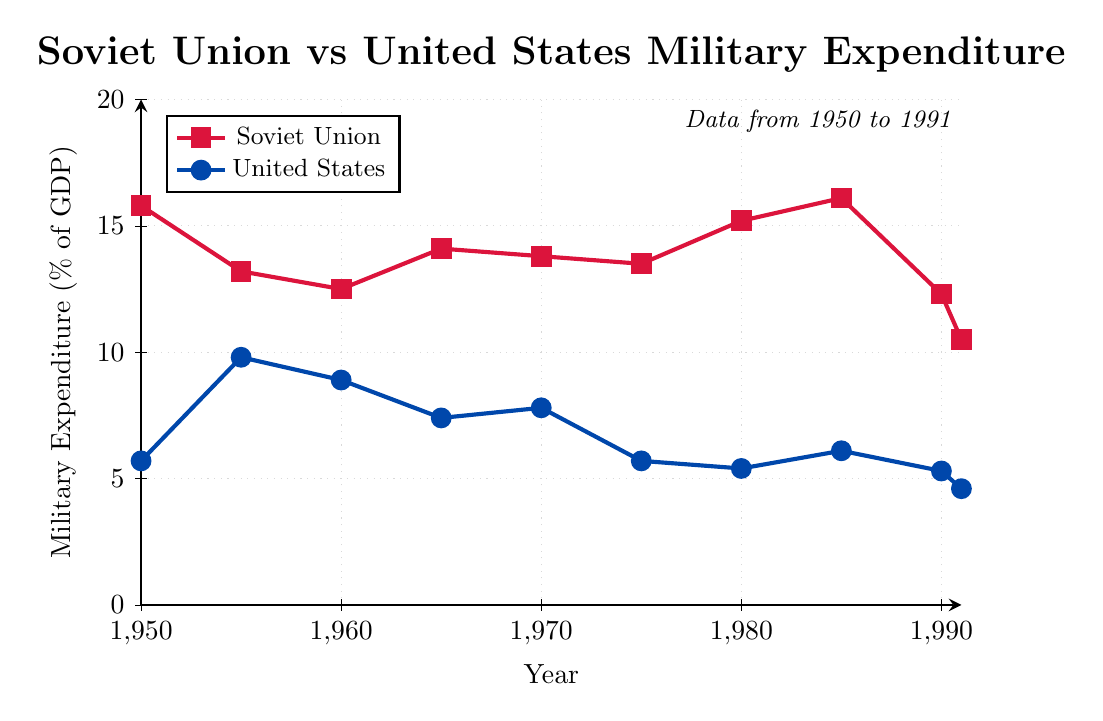What's the lowest military expenditure percentage for the Soviet Union? From the figure, the lowest point in the red line representing the Soviet Union's military expenditure is in 1991, which is 10.5% of GDP.
Answer: 10.5% Which country had a higher military expenditure percentage in 1950? By comparing the y-values at 1950 in the plot, the Soviet Union had a military expenditure of 15.8%, while the United States had 5.7%. Thus, the Soviet Union had a higher percentage.
Answer: Soviet Union During which year was the military expenditure percentage of the United States the highest? The highest point in the blue line representing the United States is in 1955, with a value of 9.8% of GDP.
Answer: 1955 What is the average military expenditure percentage for the Soviet Union from 1950 to 1991? The percentages for the Soviet Union are 15.8, 13.2, 12.5, 14.1, 13.8, 13.5, 15.2, 16.1, 12.3, and 10.5. Sum them up (15.8 + 13.2 + 12.5 + 14.1 + 13.8 + 13.5 + 15.2 + 16.1 + 12.3 + 10.5) = 136. Multiply by 10 to convert to one decimal: 1360 / 10 years = 13.6% average.
Answer: 13.6% What is the difference in military expenditure percentage between the Soviet Union and the United States in 1985? In 1985, the Soviet Union's military expenditure was 16.1%, and the United States' was 6.1%. The difference is 16.1% - 6.1% = 10%.
Answer: 10% What trend do you observe in the Soviet Union's military expenditure percentage from 1980 to 1991? Looking at the red line from 1980 to 1991, the percentage starts at 15.2% in 1980, rises to 16.1% in 1985, and then falls to 10.5% by 1991. The overall trend is an initial increase followed by a steady decline.
Answer: Increase then decline In which year do the Soviet Union and the United States have the same military expenditure percentage? The plot shows that the red and blue lines cross each other in 1975, where both countries have a military expenditure of 5.7%.
Answer: 1975 What visual difference can you observe between the Soviet Union and the United States' expenditure patterns over time? The Soviet Union (red line) generally maintains higher and more fluctuating military expenditure levels, while the United States (blue line) shows lower expenditure levels with more steady declines over time.
Answer: Soviet Union higher, U.S. steady decline 